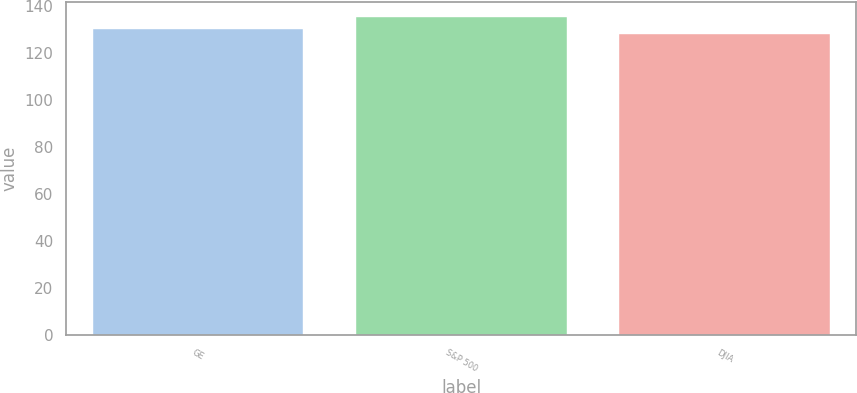Convert chart. <chart><loc_0><loc_0><loc_500><loc_500><bar_chart><fcel>GE<fcel>S&P 500<fcel>DJIA<nl><fcel>130<fcel>135<fcel>128<nl></chart> 